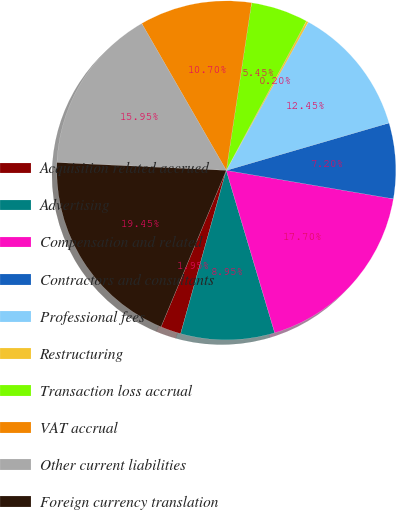<chart> <loc_0><loc_0><loc_500><loc_500><pie_chart><fcel>Acquisition related accrued<fcel>Advertising<fcel>Compensation and related<fcel>Contractors and consultants<fcel>Professional fees<fcel>Restructuring<fcel>Transaction loss accrual<fcel>VAT accrual<fcel>Other current liabilities<fcel>Foreign currency translation<nl><fcel>1.95%<fcel>8.95%<fcel>17.7%<fcel>7.2%<fcel>12.45%<fcel>0.2%<fcel>5.45%<fcel>10.7%<fcel>15.95%<fcel>19.45%<nl></chart> 